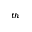<formula> <loc_0><loc_0><loc_500><loc_500>^ { t h }</formula> 